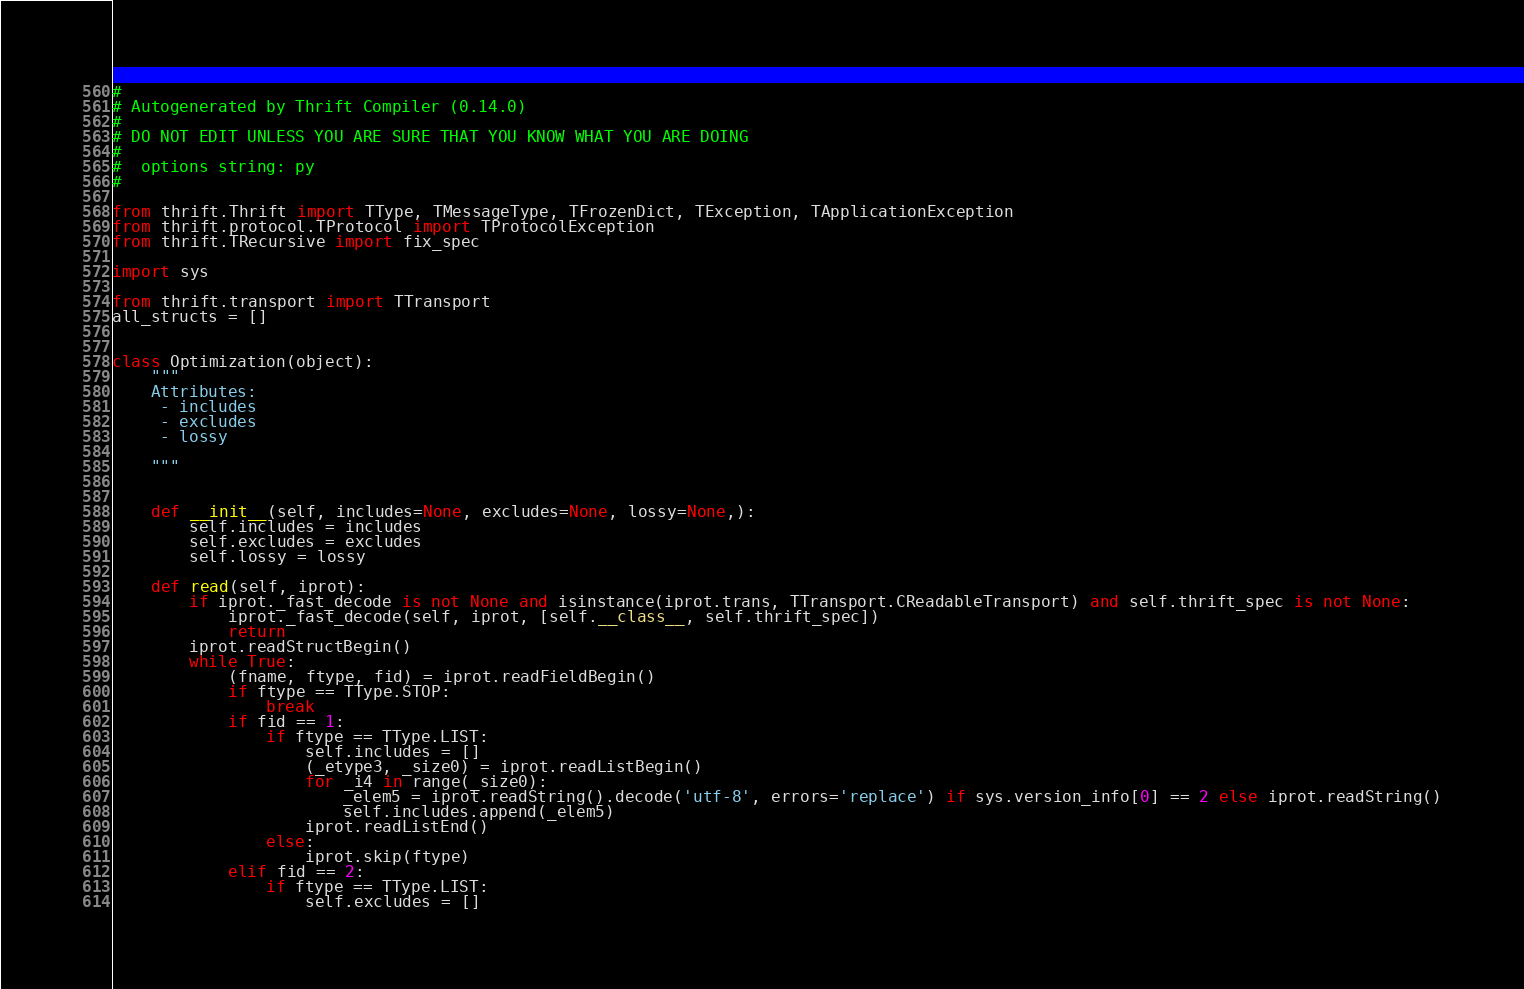<code> <loc_0><loc_0><loc_500><loc_500><_Python_>#
# Autogenerated by Thrift Compiler (0.14.0)
#
# DO NOT EDIT UNLESS YOU ARE SURE THAT YOU KNOW WHAT YOU ARE DOING
#
#  options string: py
#

from thrift.Thrift import TType, TMessageType, TFrozenDict, TException, TApplicationException
from thrift.protocol.TProtocol import TProtocolException
from thrift.TRecursive import fix_spec

import sys

from thrift.transport import TTransport
all_structs = []


class Optimization(object):
    """
    Attributes:
     - includes
     - excludes
     - lossy

    """


    def __init__(self, includes=None, excludes=None, lossy=None,):
        self.includes = includes
        self.excludes = excludes
        self.lossy = lossy

    def read(self, iprot):
        if iprot._fast_decode is not None and isinstance(iprot.trans, TTransport.CReadableTransport) and self.thrift_spec is not None:
            iprot._fast_decode(self, iprot, [self.__class__, self.thrift_spec])
            return
        iprot.readStructBegin()
        while True:
            (fname, ftype, fid) = iprot.readFieldBegin()
            if ftype == TType.STOP:
                break
            if fid == 1:
                if ftype == TType.LIST:
                    self.includes = []
                    (_etype3, _size0) = iprot.readListBegin()
                    for _i4 in range(_size0):
                        _elem5 = iprot.readString().decode('utf-8', errors='replace') if sys.version_info[0] == 2 else iprot.readString()
                        self.includes.append(_elem5)
                    iprot.readListEnd()
                else:
                    iprot.skip(ftype)
            elif fid == 2:
                if ftype == TType.LIST:
                    self.excludes = []</code> 